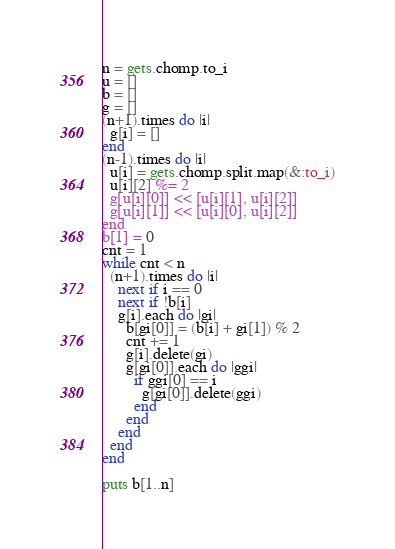<code> <loc_0><loc_0><loc_500><loc_500><_Ruby_>n = gets.chomp.to_i
u = []
b = []
g = []
(n+1).times do |i|
  g[i] = []
end
(n-1).times do |i|
  u[i] = gets.chomp.split.map(&:to_i)
  u[i][2] %= 2
  g[u[i][0]] << [u[i][1], u[i][2]]
  g[u[i][1]] << [u[i][0], u[i][2]]
end
b[1] = 0
cnt = 1
while cnt < n
  (n+1).times do |i|
    next if i == 0
    next if !b[i]
    g[i].each do |gi|
      b[gi[0]] = (b[i] + gi[1]) % 2
      cnt += 1
      g[i].delete(gi)
      g[gi[0]].each do |ggi|
        if ggi[0] == i
          g[gi[0]].delete(ggi)
        end
      end
    end
  end
end

puts b[1..n]</code> 